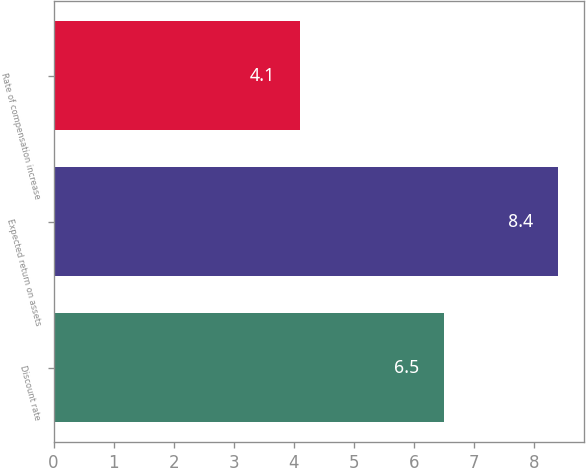Convert chart to OTSL. <chart><loc_0><loc_0><loc_500><loc_500><bar_chart><fcel>Discount rate<fcel>Expected return on assets<fcel>Rate of compensation increase<nl><fcel>6.5<fcel>8.4<fcel>4.1<nl></chart> 